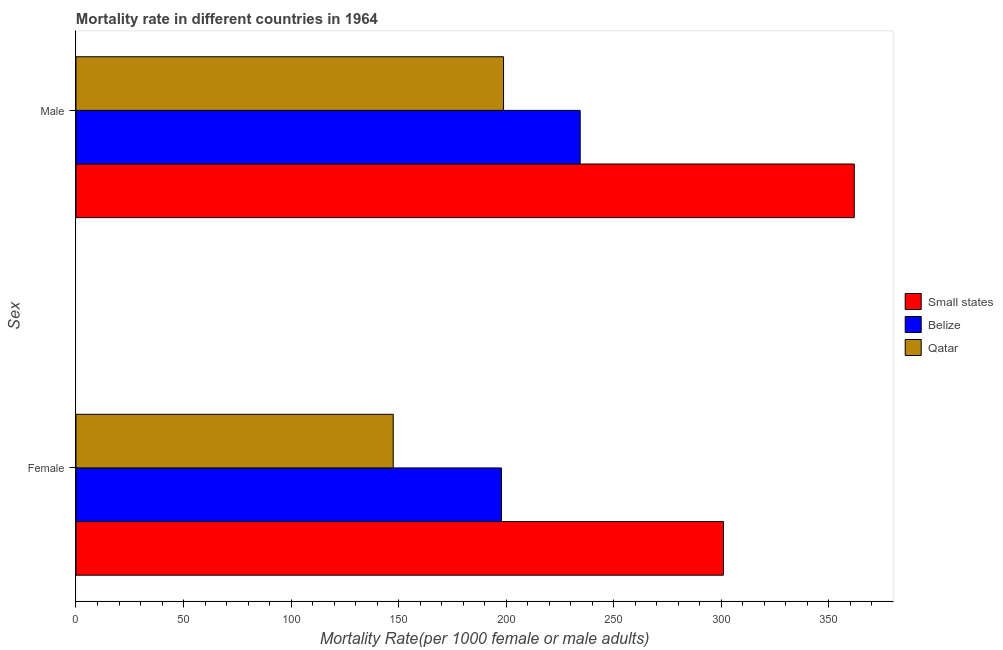How many different coloured bars are there?
Your answer should be compact. 3. Are the number of bars per tick equal to the number of legend labels?
Make the answer very short. Yes. Are the number of bars on each tick of the Y-axis equal?
Keep it short and to the point. Yes. What is the label of the 1st group of bars from the top?
Give a very brief answer. Male. What is the female mortality rate in Belize?
Make the answer very short. 197.8. Across all countries, what is the maximum female mortality rate?
Provide a short and direct response. 301.01. Across all countries, what is the minimum female mortality rate?
Give a very brief answer. 147.49. In which country was the male mortality rate maximum?
Keep it short and to the point. Small states. In which country was the female mortality rate minimum?
Make the answer very short. Qatar. What is the total male mortality rate in the graph?
Provide a short and direct response. 795.02. What is the difference between the male mortality rate in Belize and that in Small states?
Your response must be concise. -127.43. What is the difference between the male mortality rate in Qatar and the female mortality rate in Belize?
Offer a very short reply. 0.98. What is the average male mortality rate per country?
Offer a very short reply. 265.01. What is the difference between the female mortality rate and male mortality rate in Small states?
Your answer should be very brief. -60.82. What is the ratio of the male mortality rate in Qatar to that in Belize?
Your answer should be compact. 0.85. Is the male mortality rate in Qatar less than that in Belize?
Your response must be concise. Yes. In how many countries, is the male mortality rate greater than the average male mortality rate taken over all countries?
Offer a very short reply. 1. What does the 1st bar from the top in Female represents?
Provide a short and direct response. Qatar. What does the 3rd bar from the bottom in Male represents?
Your answer should be very brief. Qatar. How many bars are there?
Give a very brief answer. 6. Are all the bars in the graph horizontal?
Make the answer very short. Yes. Are the values on the major ticks of X-axis written in scientific E-notation?
Your answer should be very brief. No. Does the graph contain any zero values?
Keep it short and to the point. No. How many legend labels are there?
Give a very brief answer. 3. How are the legend labels stacked?
Keep it short and to the point. Vertical. What is the title of the graph?
Keep it short and to the point. Mortality rate in different countries in 1964. Does "Upper middle income" appear as one of the legend labels in the graph?
Your answer should be compact. No. What is the label or title of the X-axis?
Keep it short and to the point. Mortality Rate(per 1000 female or male adults). What is the label or title of the Y-axis?
Ensure brevity in your answer.  Sex. What is the Mortality Rate(per 1000 female or male adults) in Small states in Female?
Your answer should be compact. 301.01. What is the Mortality Rate(per 1000 female or male adults) of Belize in Female?
Give a very brief answer. 197.8. What is the Mortality Rate(per 1000 female or male adults) of Qatar in Female?
Keep it short and to the point. 147.49. What is the Mortality Rate(per 1000 female or male adults) in Small states in Male?
Give a very brief answer. 361.83. What is the Mortality Rate(per 1000 female or male adults) in Belize in Male?
Offer a very short reply. 234.4. What is the Mortality Rate(per 1000 female or male adults) of Qatar in Male?
Offer a very short reply. 198.78. Across all Sex, what is the maximum Mortality Rate(per 1000 female or male adults) in Small states?
Your response must be concise. 361.83. Across all Sex, what is the maximum Mortality Rate(per 1000 female or male adults) in Belize?
Your answer should be compact. 234.4. Across all Sex, what is the maximum Mortality Rate(per 1000 female or male adults) in Qatar?
Your response must be concise. 198.78. Across all Sex, what is the minimum Mortality Rate(per 1000 female or male adults) in Small states?
Offer a very short reply. 301.01. Across all Sex, what is the minimum Mortality Rate(per 1000 female or male adults) in Belize?
Make the answer very short. 197.8. Across all Sex, what is the minimum Mortality Rate(per 1000 female or male adults) in Qatar?
Provide a short and direct response. 147.49. What is the total Mortality Rate(per 1000 female or male adults) of Small states in the graph?
Ensure brevity in your answer.  662.84. What is the total Mortality Rate(per 1000 female or male adults) in Belize in the graph?
Keep it short and to the point. 432.21. What is the total Mortality Rate(per 1000 female or male adults) of Qatar in the graph?
Keep it short and to the point. 346.27. What is the difference between the Mortality Rate(per 1000 female or male adults) in Small states in Female and that in Male?
Your answer should be compact. -60.82. What is the difference between the Mortality Rate(per 1000 female or male adults) of Belize in Female and that in Male?
Your answer should be compact. -36.6. What is the difference between the Mortality Rate(per 1000 female or male adults) in Qatar in Female and that in Male?
Provide a succinct answer. -51.29. What is the difference between the Mortality Rate(per 1000 female or male adults) of Small states in Female and the Mortality Rate(per 1000 female or male adults) of Belize in Male?
Keep it short and to the point. 66.61. What is the difference between the Mortality Rate(per 1000 female or male adults) in Small states in Female and the Mortality Rate(per 1000 female or male adults) in Qatar in Male?
Your answer should be very brief. 102.23. What is the difference between the Mortality Rate(per 1000 female or male adults) of Belize in Female and the Mortality Rate(per 1000 female or male adults) of Qatar in Male?
Your answer should be compact. -0.98. What is the average Mortality Rate(per 1000 female or male adults) of Small states per Sex?
Provide a short and direct response. 331.42. What is the average Mortality Rate(per 1000 female or male adults) in Belize per Sex?
Your response must be concise. 216.1. What is the average Mortality Rate(per 1000 female or male adults) of Qatar per Sex?
Your answer should be very brief. 173.13. What is the difference between the Mortality Rate(per 1000 female or male adults) in Small states and Mortality Rate(per 1000 female or male adults) in Belize in Female?
Give a very brief answer. 103.21. What is the difference between the Mortality Rate(per 1000 female or male adults) of Small states and Mortality Rate(per 1000 female or male adults) of Qatar in Female?
Ensure brevity in your answer.  153.52. What is the difference between the Mortality Rate(per 1000 female or male adults) of Belize and Mortality Rate(per 1000 female or male adults) of Qatar in Female?
Your answer should be very brief. 50.31. What is the difference between the Mortality Rate(per 1000 female or male adults) of Small states and Mortality Rate(per 1000 female or male adults) of Belize in Male?
Make the answer very short. 127.43. What is the difference between the Mortality Rate(per 1000 female or male adults) in Small states and Mortality Rate(per 1000 female or male adults) in Qatar in Male?
Ensure brevity in your answer.  163.05. What is the difference between the Mortality Rate(per 1000 female or male adults) of Belize and Mortality Rate(per 1000 female or male adults) of Qatar in Male?
Make the answer very short. 35.62. What is the ratio of the Mortality Rate(per 1000 female or male adults) in Small states in Female to that in Male?
Your response must be concise. 0.83. What is the ratio of the Mortality Rate(per 1000 female or male adults) of Belize in Female to that in Male?
Provide a short and direct response. 0.84. What is the ratio of the Mortality Rate(per 1000 female or male adults) in Qatar in Female to that in Male?
Provide a succinct answer. 0.74. What is the difference between the highest and the second highest Mortality Rate(per 1000 female or male adults) of Small states?
Make the answer very short. 60.82. What is the difference between the highest and the second highest Mortality Rate(per 1000 female or male adults) in Belize?
Offer a very short reply. 36.6. What is the difference between the highest and the second highest Mortality Rate(per 1000 female or male adults) of Qatar?
Provide a succinct answer. 51.29. What is the difference between the highest and the lowest Mortality Rate(per 1000 female or male adults) of Small states?
Ensure brevity in your answer.  60.82. What is the difference between the highest and the lowest Mortality Rate(per 1000 female or male adults) in Belize?
Provide a short and direct response. 36.6. What is the difference between the highest and the lowest Mortality Rate(per 1000 female or male adults) in Qatar?
Make the answer very short. 51.29. 